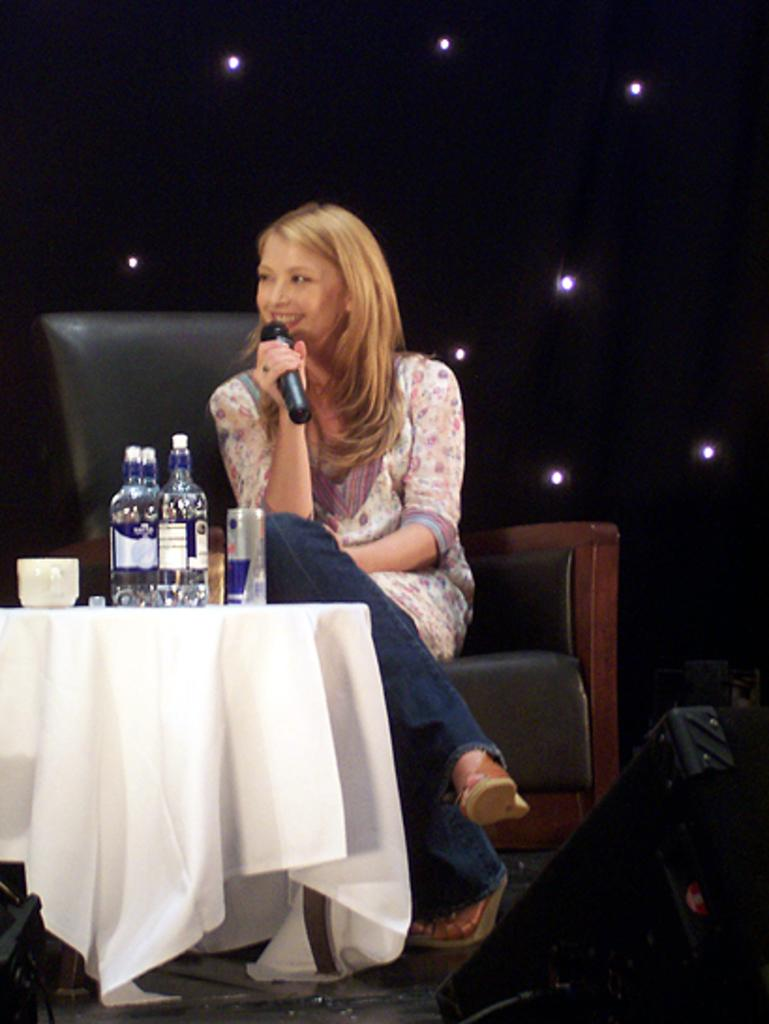Who is the main subject in the image? There is a woman in the image. What is the woman doing in the image? The woman is sitting on a chair and holding a microphone. What is present in front of the woman? There is a table in front of the woman. What items can be seen on the table? There are bottles, a cup, and a tin on the table on the table. How many books are stacked on the cart in the image? There is no cart or books present in the image. What type of seat is the woman using to hold the microphone? The woman is sitting on a chair, which is not specifically designed for holding a microphone, but it is the seat she is using in the image. 